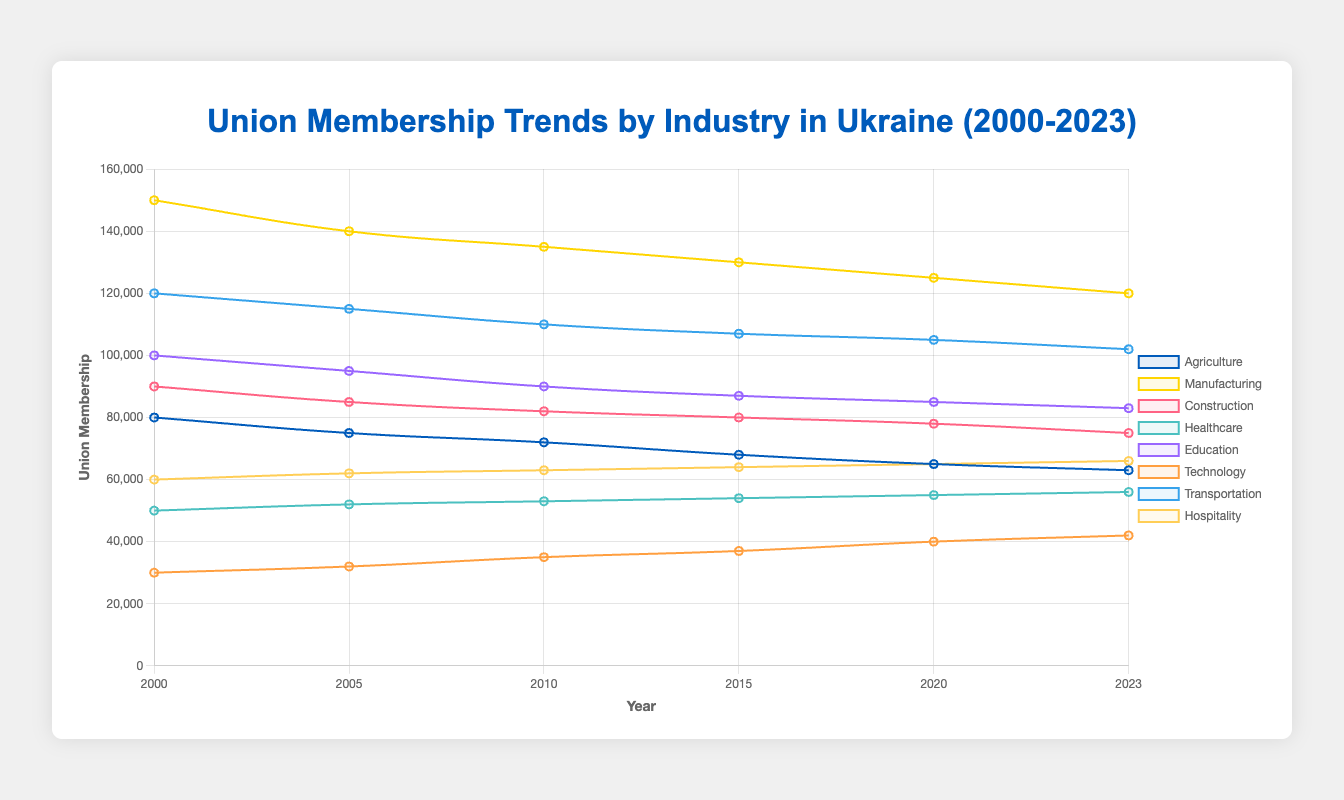What is the overall trend in union membership in the Agriculture industry from 2000 to 2023? The union membership in the Agriculture industry has steadily declined from 80,000 in 2000 to 63,000 in 2023. The trend is a continuous decrease over the years.
Answer: Decline Which industry had the highest union membership in 2023? Comparing all the union memberships across industries for 2023, Manufacturing has the highest union membership with 120,000.
Answer: Manufacturing What is the average union membership for the Healthcare industry over the years shown? The union memberships for the Healthcare industry over the years are 50,000, 52,000, 53,000, 54,000, 55,000, and 56,000. Adding these gives a total of 320,000. Dividing by 6 (the number of years) gives an average of approx. 53,333.
Answer: 53,333 Which industry shows an increasing trend in union membership from 2000 to 2023? By observing the trends, the Healthcare and Hospitality industries show an increasing trend from 2000 to 2023.
Answer: Healthcare and Hospitality How has the membership in the Technology industry changed between 2000 and 2023? The union membership in Technology increased from 30,000 in 2000 to 42,000 in 2023, indicating a rising trend over the period.
Answer: Increased by 12,000 Between 2010 and 2015, which industry experienced the largest decrease in union membership? To find the largest decrease, calculate the differences: Agriculture (-4,000), Manufacturing (-5,000), Construction (-2,000), Healthcare (+1,000), Education (-3,000), Technology (+2,000), Transportation (-3,000), Hospitality (+1,000). Manufacturing experienced the largest decrease (5,000).
Answer: Manufacturing Compare the union membership in Education and Manufacturing in 2005. Which is higher and by how much? In 2005, Education had 95,000 and Manufacturing had 140,000. The difference (140,000 - 95,000) shows that Manufacturing had a higher membership by 45,000.
Answer: Manufacturing, by 45,000 Which industry had the most stable union membership from 2000 to 2023? Stability can be determined by least fluctuations. The Healthcare industry shows a gradual and consistent increase with small increments, indicating stability.
Answer: Healthcare By what percentage did the union membership in the Transportation industry decrease from 2000 to 2023? Starting from 120,000 in 2000 to 102,000 in 2023, the decrease is 18,000. The percentage decrease is (18,000 / 120,000) * 100 = 15%.
Answer: 15% In which year did the Hospitality industry have the same union membership as the Technology industry? The union memberships are compared over the years and found to be equal at 42,000 in the year 2023.
Answer: 2023 